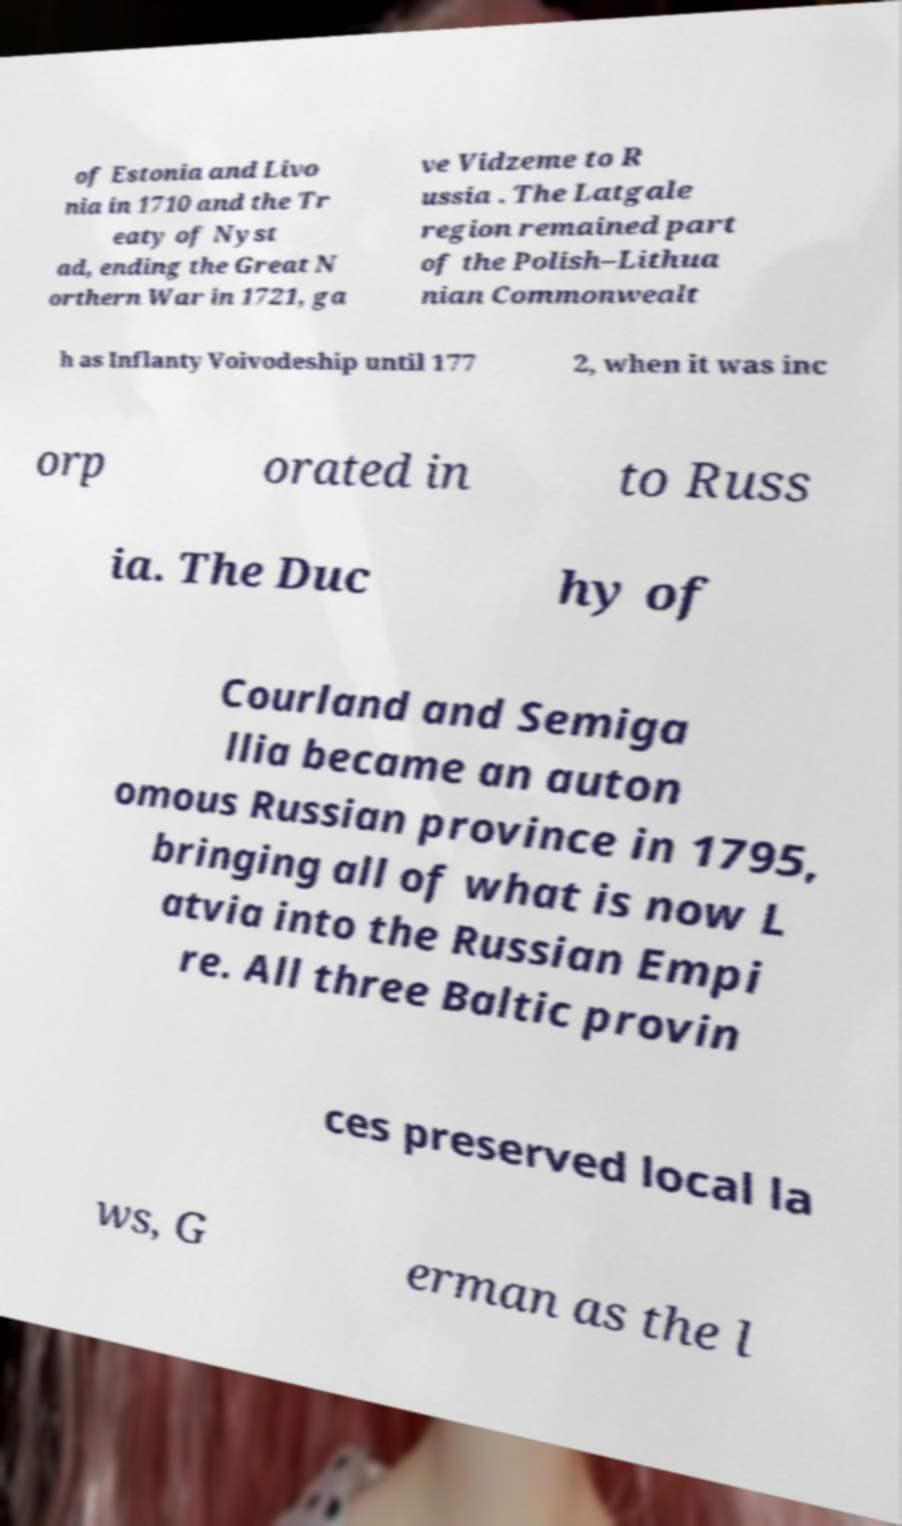Please identify and transcribe the text found in this image. of Estonia and Livo nia in 1710 and the Tr eaty of Nyst ad, ending the Great N orthern War in 1721, ga ve Vidzeme to R ussia . The Latgale region remained part of the Polish–Lithua nian Commonwealt h as Inflanty Voivodeship until 177 2, when it was inc orp orated in to Russ ia. The Duc hy of Courland and Semiga llia became an auton omous Russian province in 1795, bringing all of what is now L atvia into the Russian Empi re. All three Baltic provin ces preserved local la ws, G erman as the l 